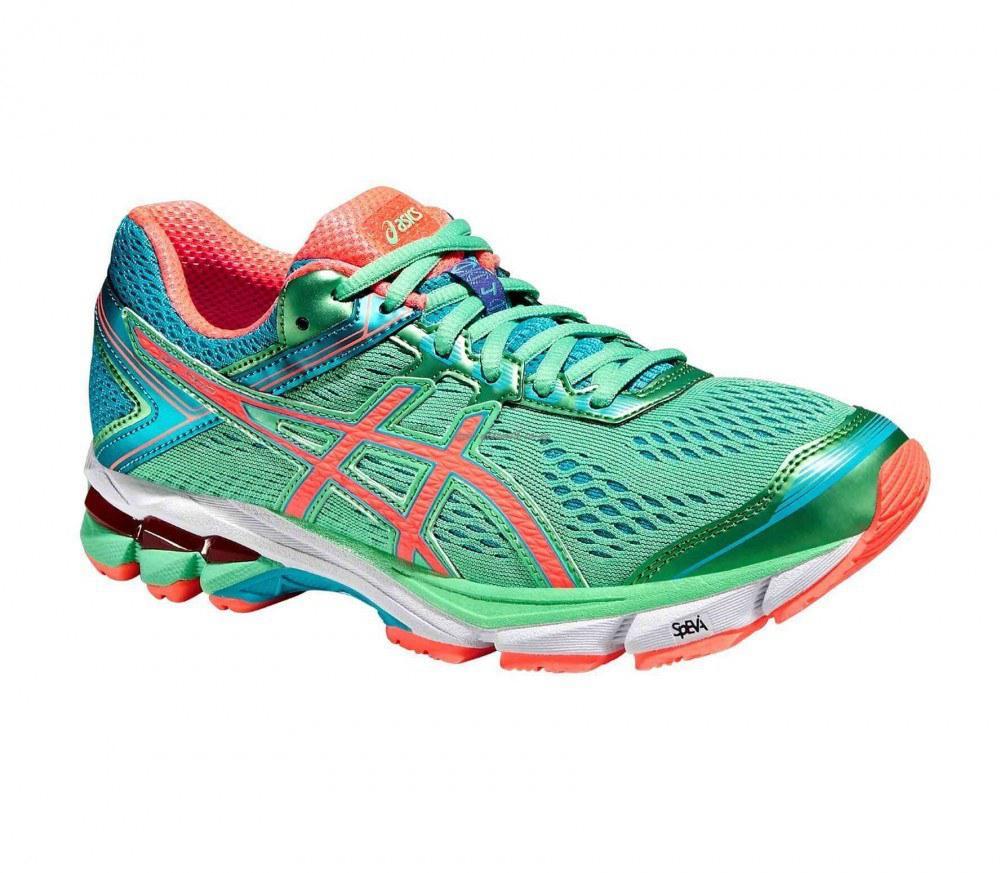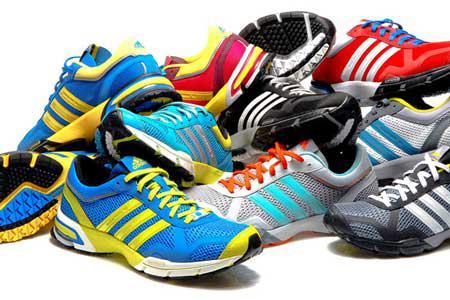The first image is the image on the left, the second image is the image on the right. Given the left and right images, does the statement "One image shows only one colorful shoe with matching laces." hold true? Answer yes or no. Yes. The first image is the image on the left, the second image is the image on the right. Considering the images on both sides, is "There is exactly one shoe in the image on the left." valid? Answer yes or no. Yes. 